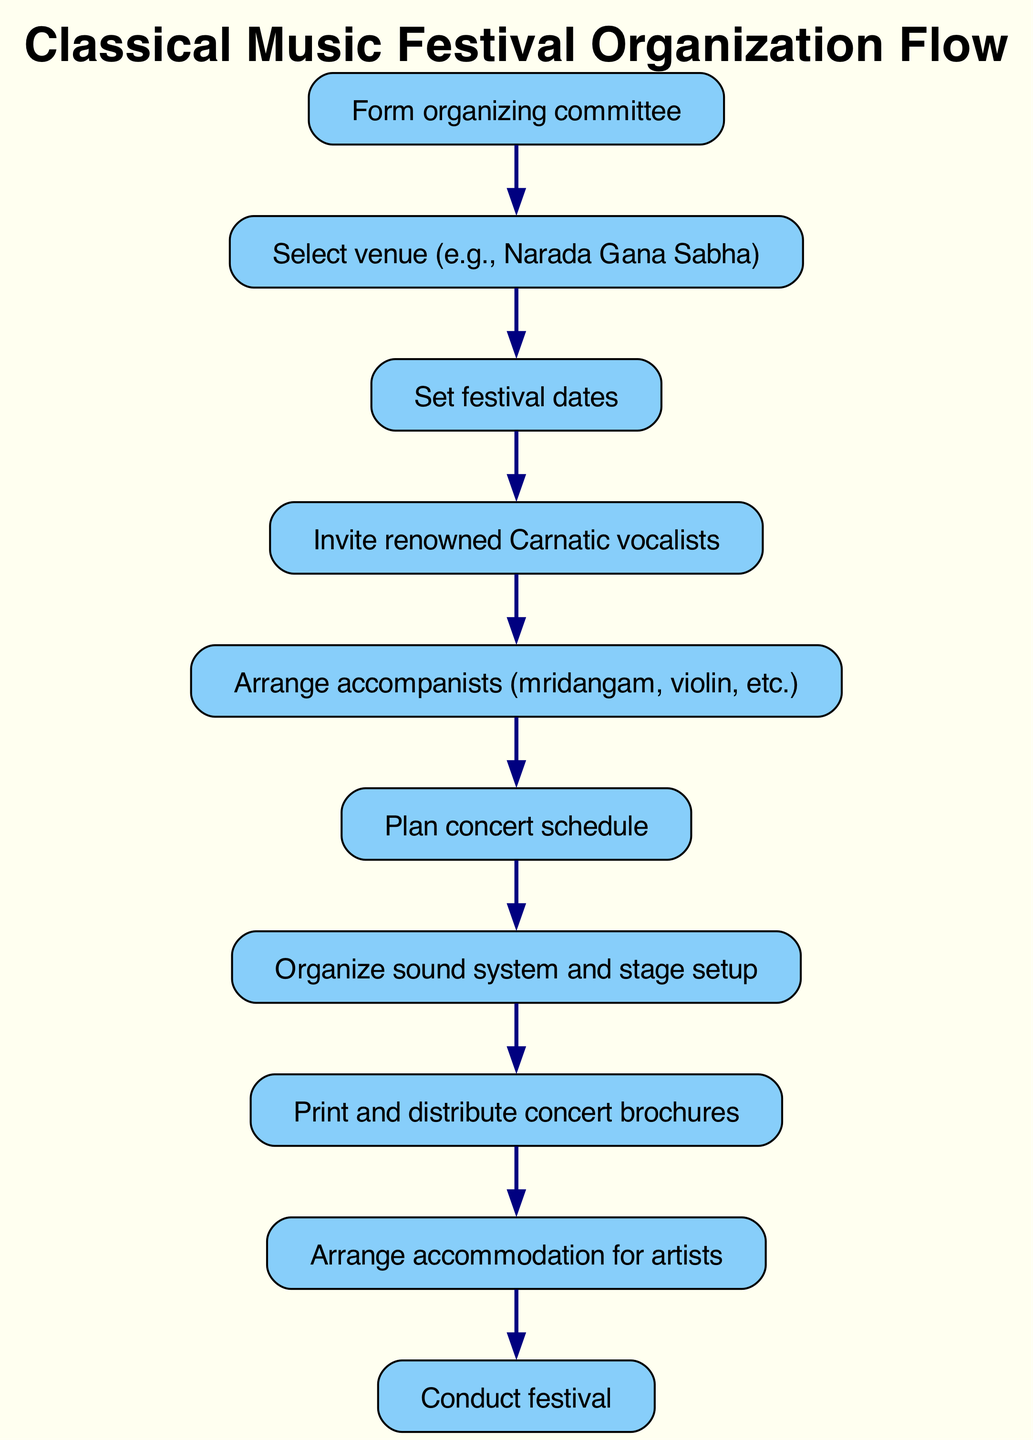What is the first step in organizing a classical music festival? The first element in the diagram signifies the initiation of the festival organization process. This is identified as "Form organizing committee," making it the first step.
Answer: Form organizing committee How many main steps are there in the festival organization process? By counting the elements in the diagram excluding the final step, we find there are ten steps involved in the organization process of the festival.
Answer: Ten What is the step that follows 'Set festival dates'? The diagram shows a sequence of instructions, and 'Set festival dates' is directly linked to the next step, which is 'Invite renowned Carnatic vocalists.'
Answer: Invite renowned Carnatic vocalists What type of artists are to be invited in the festival? The relevant node specifies the type of artists to be invited for the festival, which are 'renowned Carnatic vocalists.'
Answer: Renowned Carnatic vocalists What is the last step of the diagram? The final node in the flow chart indicates the conclusion of the process, which is 'Conduct festival.' This represents the execution stage of the planning.
Answer: Conduct festival What must be arranged before planning the concert schedule? To determine the prerequisites for planning the concert schedule, we examine the sequence leading up to it. The step 'Arrange accompanists (mridangam, violin, etc.)' must be completed first.
Answer: Arrange accompanists (mridangam, violin, etc.) Which node is connected directly to 'Organize sound system and stage setup'? Tracing the flow chart, the directly preceding node before 'Organize sound system and stage setup' is 'Plan concert schedule,' which establishes the groundwork for sound and stage arrangements.
Answer: Plan concert schedule What is required to be printed and distributed after organizing the sound system? Following the arrangement of the sound system, the next defined step is to 'Print and distribute concert brochures,' which outlines necessary promotional material for the event.
Answer: Print and distribute concert brochures What is the key action taken after inviting renowned vocalists? The immediate step that follows inviting the vocalists is 'Arrange accompanists (mridangam, violin, etc.),' indicating that arranging support musicians is essential to the festival preparation.
Answer: Arrange accompanists (mridangam, violin, etc.) 